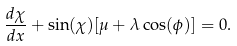<formula> <loc_0><loc_0><loc_500><loc_500>\frac { d \chi } { d x } + \sin ( \chi ) [ \mu + \lambda \cos ( \phi ) ] = 0 .</formula> 